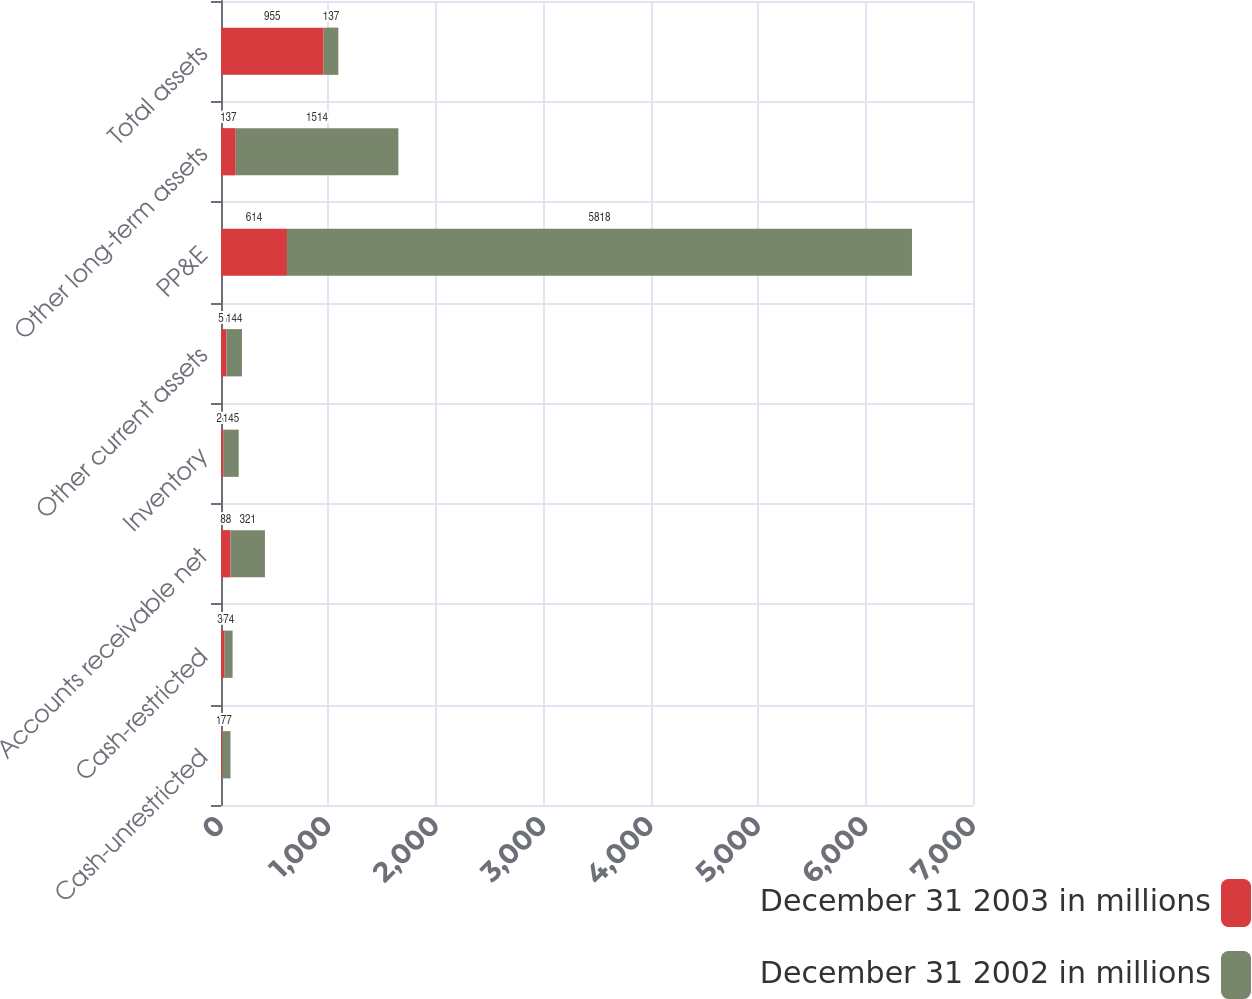<chart> <loc_0><loc_0><loc_500><loc_500><stacked_bar_chart><ecel><fcel>Cash-unrestricted<fcel>Cash-restricted<fcel>Accounts receivable net<fcel>Inventory<fcel>Other current assets<fcel>PP&E<fcel>Other long-term assets<fcel>Total assets<nl><fcel>December 31 2003 in millions<fcel>11<fcel>34<fcel>88<fcel>20<fcel>51<fcel>614<fcel>137<fcel>955<nl><fcel>December 31 2002 in millions<fcel>77<fcel>74<fcel>321<fcel>145<fcel>144<fcel>5818<fcel>1514<fcel>137<nl></chart> 